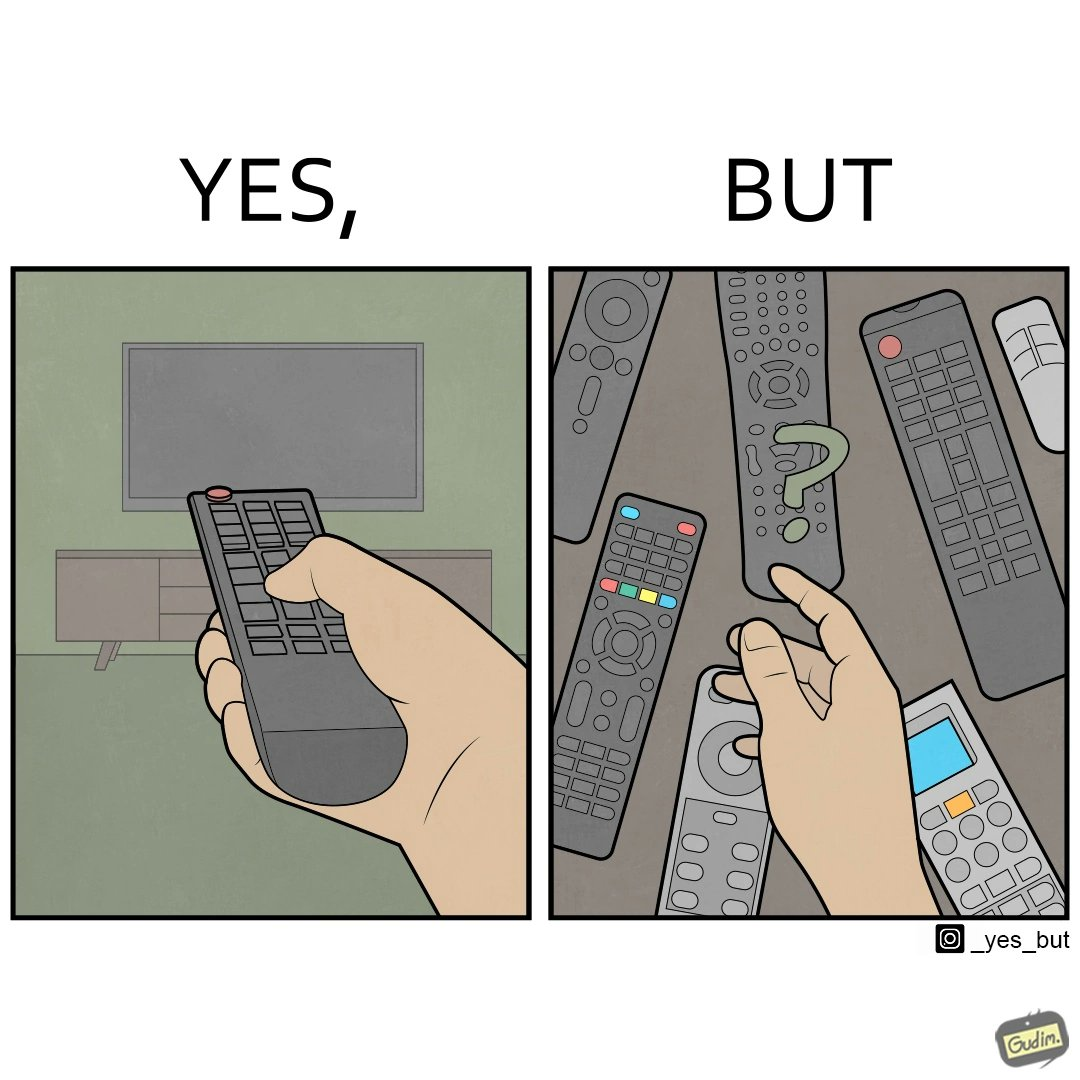Describe what you see in the left and right parts of this image. In the left part of the image: It is a remote being used to operate a TV In the right part of the image: It is an user confused between multiple remotes 